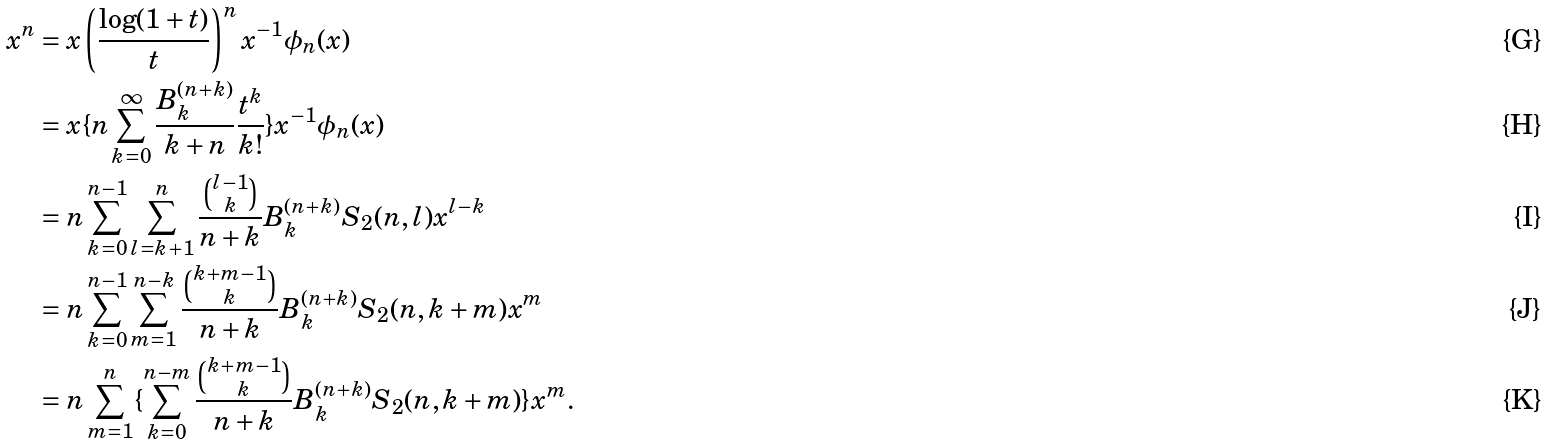Convert formula to latex. <formula><loc_0><loc_0><loc_500><loc_500>x ^ { n } & = x \left ( \frac { \log ( 1 + t ) } { t } \right ) ^ { n } x ^ { - 1 } \phi _ { n } ( x ) \\ & = x \{ n \sum _ { k = 0 } ^ { \infty } \frac { B _ { k } ^ { ( n + k ) } } { k + n } \frac { t ^ { k } } { k ! } \} x ^ { - 1 } \phi _ { n } ( x ) \\ & = n \sum _ { k = 0 } ^ { n - 1 } \sum _ { l = k + 1 } ^ { n } \frac { \binom { l - 1 } { k } } { n + k } B _ { k } ^ { ( n + k ) } S _ { 2 } ( n , l ) x ^ { l - k } \\ & = n \sum _ { k = 0 } ^ { n - 1 } \sum _ { m = 1 } ^ { n - k } \frac { \binom { k + m - 1 } { k } } { n + k } B _ { k } ^ { ( n + k ) } S _ { 2 } ( n , k + m ) x ^ { m } \\ & = n \sum _ { m = 1 } ^ { n } \{ \sum _ { k = 0 } ^ { n - m } \frac { \binom { k + m - 1 } { k } } { n + k } B _ { k } ^ { ( n + k ) } S _ { 2 } ( n , k + m ) \} x ^ { m } .</formula> 